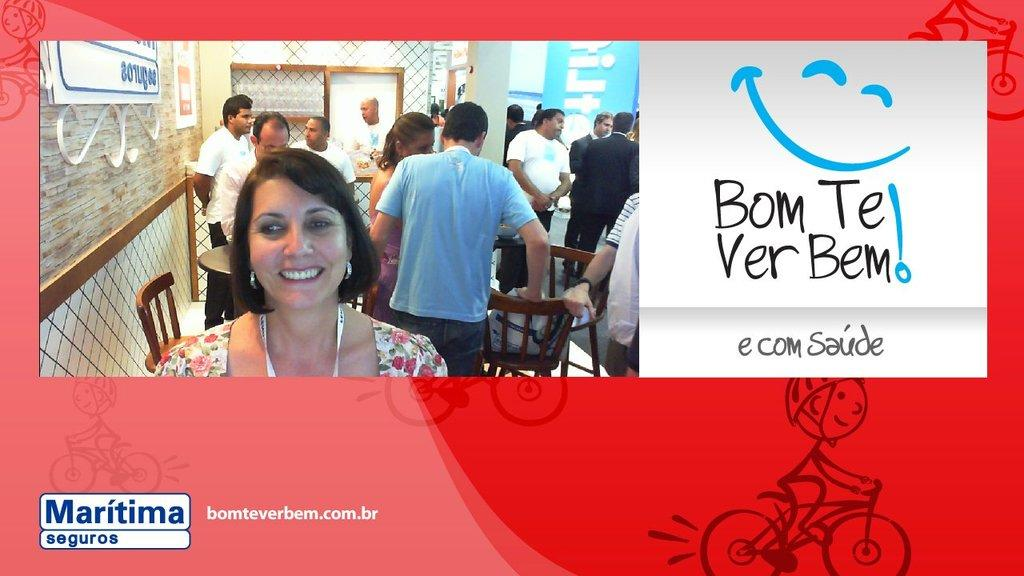What is the main subject of the image? The main subject of the image is a group of people standing. Can you describe any additional elements in the image? Yes, there is text on the right side of the image. What type of toe is being discussed by the group of people in the image? There is no discussion or mention of toes in the image; it features a group of people standing and text on the right side. 